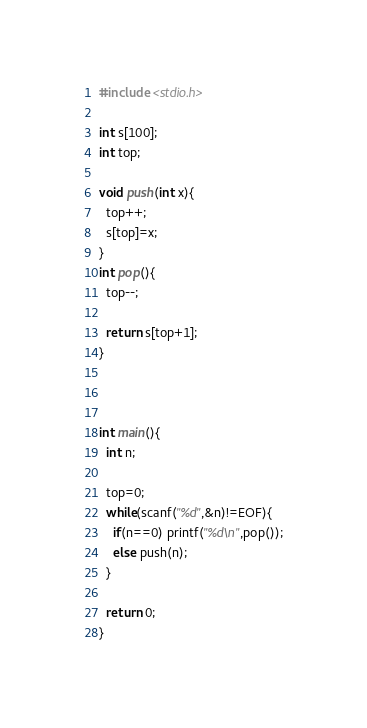Convert code to text. <code><loc_0><loc_0><loc_500><loc_500><_C_>#include <stdio.h>

int s[100];
int top;

void push(int x){
  top++;
  s[top]=x;
}
int pop(){
  top--;

  return s[top+1];
}



int main(){
  int n;

  top=0;
  while(scanf("%d",&n)!=EOF){
    if(n==0) printf("%d\n",pop());
    else push(n);
  }

  return 0;
}</code> 